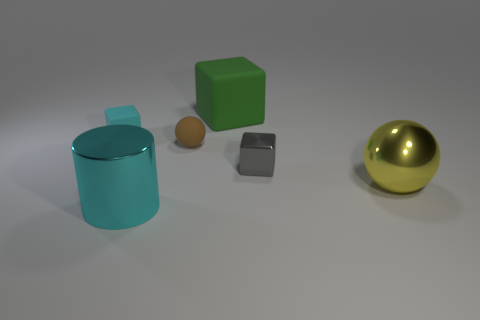Subtract all purple blocks. Subtract all yellow spheres. How many blocks are left? 3 Add 4 green rubber objects. How many objects exist? 10 Subtract all balls. How many objects are left? 4 Subtract all tiny gray rubber cylinders. Subtract all cyan objects. How many objects are left? 4 Add 2 tiny things. How many tiny things are left? 5 Add 2 big purple cubes. How many big purple cubes exist? 2 Subtract 0 blue cylinders. How many objects are left? 6 